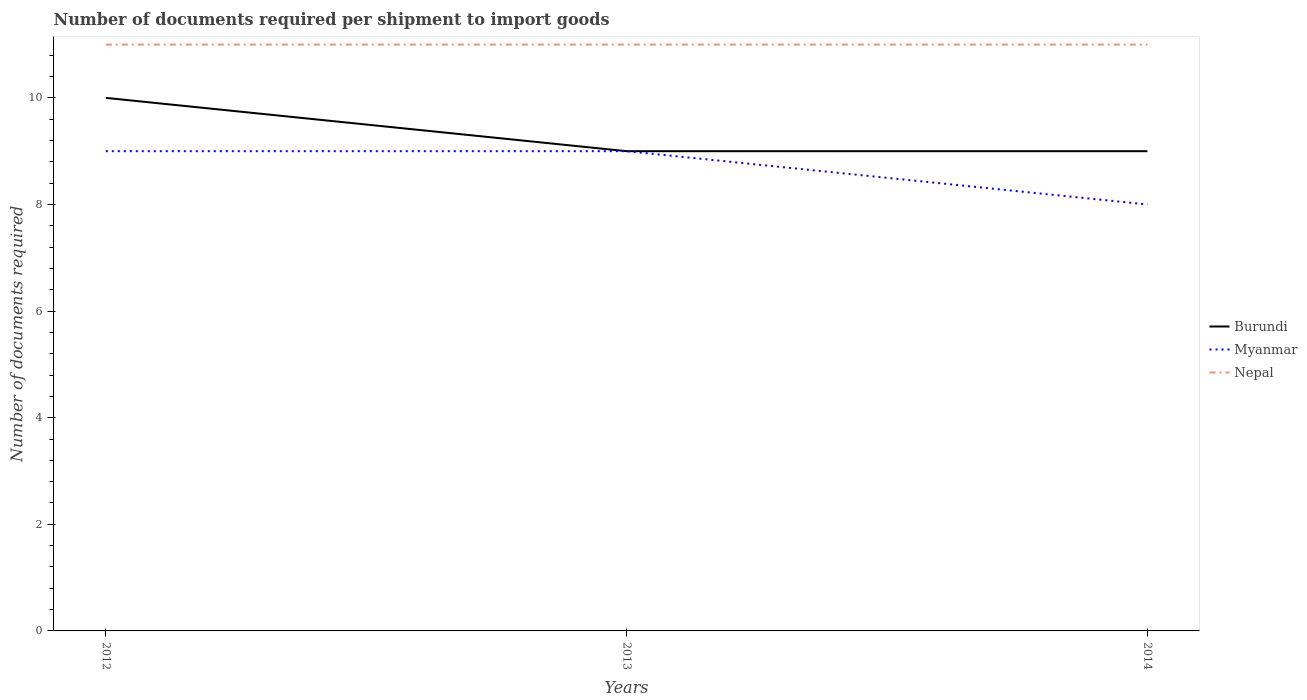Does the line corresponding to Nepal intersect with the line corresponding to Myanmar?
Your response must be concise. No. Is the number of lines equal to the number of legend labels?
Provide a short and direct response. Yes. Across all years, what is the maximum number of documents required per shipment to import goods in Burundi?
Provide a succinct answer. 9. In which year was the number of documents required per shipment to import goods in Nepal maximum?
Offer a very short reply. 2012. What is the total number of documents required per shipment to import goods in Nepal in the graph?
Provide a short and direct response. 0. What is the difference between the highest and the second highest number of documents required per shipment to import goods in Burundi?
Offer a very short reply. 1. How many lines are there?
Your answer should be compact. 3. How many years are there in the graph?
Give a very brief answer. 3. Does the graph contain grids?
Your answer should be compact. No. How many legend labels are there?
Your answer should be very brief. 3. How are the legend labels stacked?
Your response must be concise. Vertical. What is the title of the graph?
Give a very brief answer. Number of documents required per shipment to import goods. Does "Chad" appear as one of the legend labels in the graph?
Keep it short and to the point. No. What is the label or title of the X-axis?
Make the answer very short. Years. What is the label or title of the Y-axis?
Offer a very short reply. Number of documents required. What is the Number of documents required of Burundi in 2012?
Your answer should be compact. 10. What is the Number of documents required in Burundi in 2013?
Offer a very short reply. 9. What is the Number of documents required of Myanmar in 2013?
Give a very brief answer. 9. What is the Number of documents required in Nepal in 2013?
Offer a terse response. 11. What is the Number of documents required of Burundi in 2014?
Keep it short and to the point. 9. What is the Number of documents required of Myanmar in 2014?
Ensure brevity in your answer.  8. What is the Number of documents required of Nepal in 2014?
Ensure brevity in your answer.  11. Across all years, what is the maximum Number of documents required of Myanmar?
Offer a terse response. 9. Across all years, what is the maximum Number of documents required of Nepal?
Give a very brief answer. 11. Across all years, what is the minimum Number of documents required in Nepal?
Provide a short and direct response. 11. What is the difference between the Number of documents required of Nepal in 2012 and that in 2013?
Your answer should be compact. 0. What is the difference between the Number of documents required in Burundi in 2012 and that in 2014?
Make the answer very short. 1. What is the difference between the Number of documents required in Burundi in 2012 and the Number of documents required in Myanmar in 2014?
Provide a succinct answer. 2. What is the difference between the Number of documents required in Burundi in 2013 and the Number of documents required in Myanmar in 2014?
Your answer should be compact. 1. What is the difference between the Number of documents required of Burundi in 2013 and the Number of documents required of Nepal in 2014?
Ensure brevity in your answer.  -2. What is the difference between the Number of documents required of Myanmar in 2013 and the Number of documents required of Nepal in 2014?
Offer a terse response. -2. What is the average Number of documents required in Burundi per year?
Ensure brevity in your answer.  9.33. What is the average Number of documents required of Myanmar per year?
Provide a succinct answer. 8.67. What is the average Number of documents required in Nepal per year?
Your response must be concise. 11. In the year 2013, what is the difference between the Number of documents required of Burundi and Number of documents required of Myanmar?
Your answer should be compact. 0. In the year 2014, what is the difference between the Number of documents required in Burundi and Number of documents required in Nepal?
Provide a succinct answer. -2. In the year 2014, what is the difference between the Number of documents required of Myanmar and Number of documents required of Nepal?
Give a very brief answer. -3. What is the ratio of the Number of documents required in Myanmar in 2012 to that in 2013?
Offer a very short reply. 1. What is the ratio of the Number of documents required in Nepal in 2012 to that in 2013?
Your answer should be very brief. 1. What is the ratio of the Number of documents required of Myanmar in 2012 to that in 2014?
Provide a short and direct response. 1.12. What is the ratio of the Number of documents required of Nepal in 2012 to that in 2014?
Give a very brief answer. 1. What is the ratio of the Number of documents required in Burundi in 2013 to that in 2014?
Provide a succinct answer. 1. What is the ratio of the Number of documents required in Myanmar in 2013 to that in 2014?
Make the answer very short. 1.12. What is the difference between the highest and the second highest Number of documents required in Myanmar?
Keep it short and to the point. 0. 